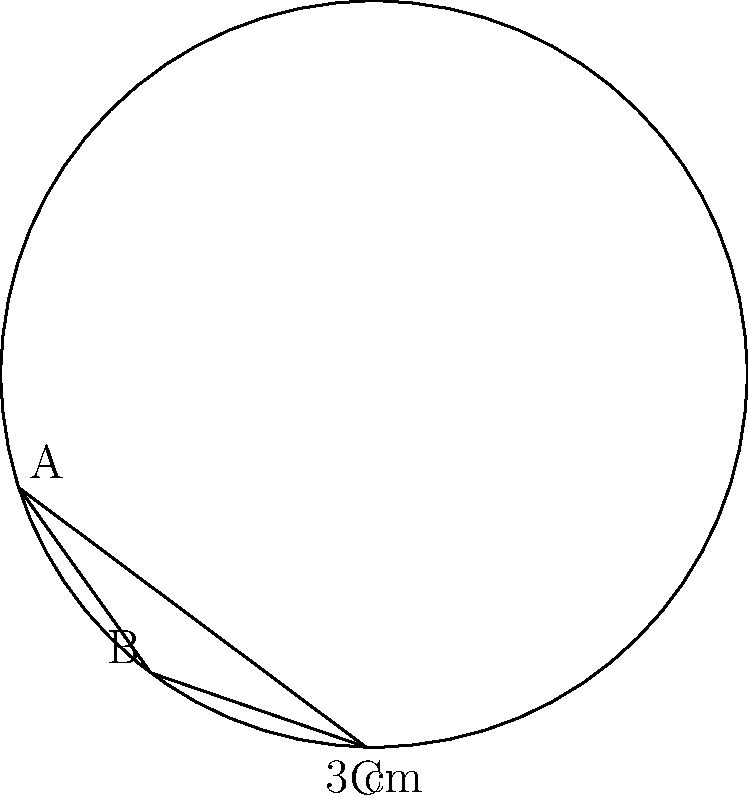In memory of Sister Kate, you want to create a circular wreath with a triangular ribbon arrangement. The wreath has a radius of 3 cm, and the ribbon forms an equilateral triangle inscribed within the circle. How much ribbon do you need to create this arrangement, rounded to the nearest centimeter? To find the length of ribbon needed, we need to calculate the perimeter of the inscribed equilateral triangle:

1. In an inscribed equilateral triangle, the side length is related to the radius of the circle by the formula:
   $$s = r\sqrt{3}$$
   where $s$ is the side length and $r$ is the radius.

2. Substitute the given radius:
   $$s = 3\sqrt{3}$$ cm

3. The perimeter of the triangle is the sum of its three sides:
   $$P = 3s = 3(3\sqrt{3}) = 9\sqrt{3}$$ cm

4. Calculate the value:
   $$9\sqrt{3} \approx 15.588$$ cm

5. Rounding to the nearest centimeter:
   15.588 cm ≈ 16 cm

Therefore, you need approximately 16 cm of ribbon for the commemorative wreath.
Answer: 16 cm 